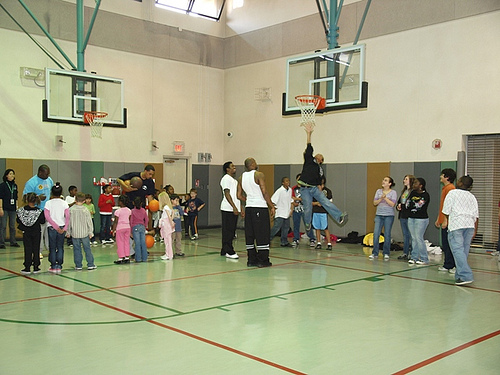<image>
Can you confirm if the child is next to the man? No. The child is not positioned next to the man. They are located in different areas of the scene. Where is the hoop in relation to the kid? Is it above the kid? Yes. The hoop is positioned above the kid in the vertical space, higher up in the scene. 